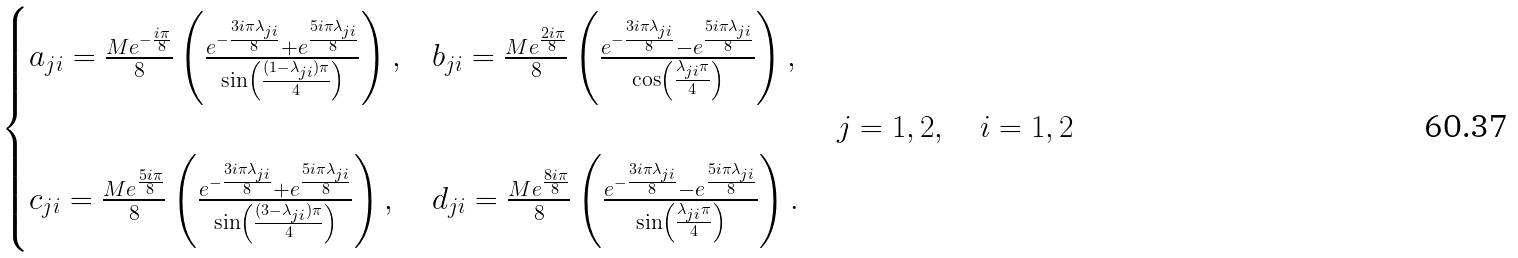Convert formula to latex. <formula><loc_0><loc_0><loc_500><loc_500>\begin{cases} a _ { j i } = \frac { M e ^ { - \frac { i \pi } { 8 } } } { 8 } \left ( \frac { e ^ { - \frac { 3 i \pi \lambda _ { j i } } { 8 } } + e ^ { \frac { 5 i \pi \lambda _ { j i } } { 8 } } } { \sin \left ( \frac { ( 1 - \lambda _ { j i } ) \pi } { 4 } \right ) } \right ) , & b _ { j i } = \frac { M e ^ { \frac { 2 i \pi } { 8 } } } { 8 } \left ( \frac { e ^ { - \frac { 3 i \pi \lambda _ { j i } } { 8 } } - e ^ { \frac { 5 i \pi \lambda _ { j i } } { 8 } } } { \cos \left ( \frac { \lambda _ { j i } \pi } { 4 } \right ) } \right ) , \\ \\ c _ { j i } = \frac { M e ^ { \frac { 5 i \pi } { 8 } } } { 8 } \left ( \frac { e ^ { - \frac { 3 i \pi \lambda _ { j i } } { 8 } } + e ^ { \frac { 5 i \pi \lambda _ { j i } } { 8 } } } { \sin \left ( \frac { ( 3 - \lambda _ { j i } ) \pi } { 4 } \right ) } \right ) , & d _ { j i } = \frac { M e ^ { \frac { 8 i \pi } { 8 } } } { 8 } \left ( \frac { e ^ { - \frac { 3 i \pi \lambda _ { j i } } { 8 } } - e ^ { \frac { 5 i \pi \lambda _ { j i } } { 8 } } } { \sin \left ( \frac { \lambda _ { j i } \pi } { 4 } \right ) } \right ) . \end{cases} \quad j = 1 , 2 , \quad i = 1 , 2</formula> 